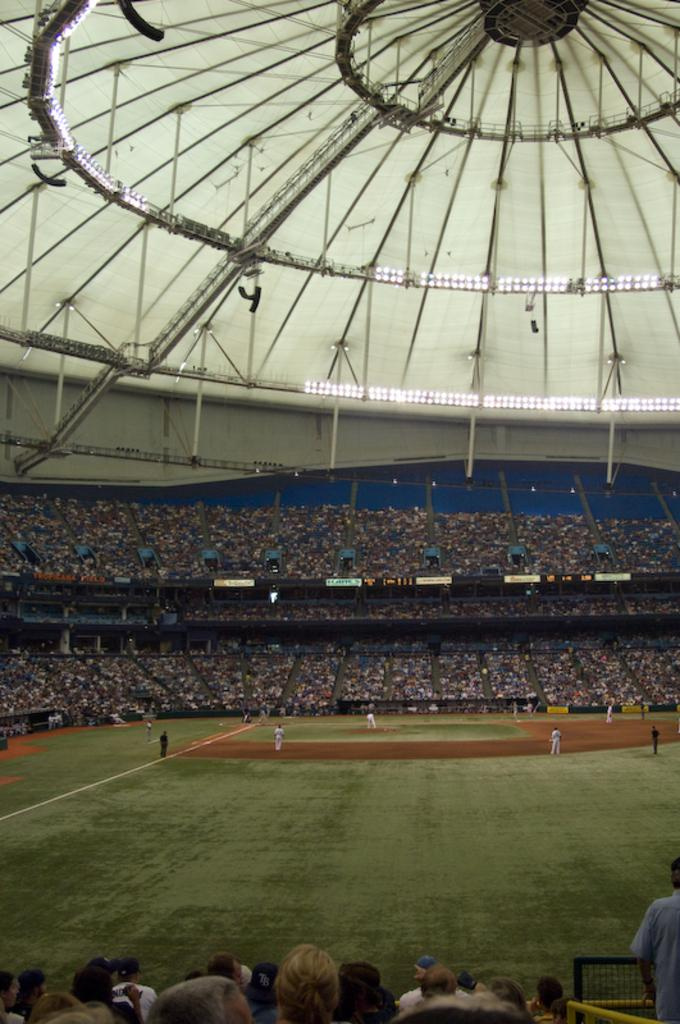What type of structure is shown in the image? There is a stadium in the image. Can you describe the people in the image? There is a group of people in the image, and some of them are standing on the ground. What type of surface is visible in the image? There is grass visible in the image. What marking can be seen on the ground? There is a white line on the ground. What historical event is being commemorated by the group of people in the image? There is no indication of a historical event being commemorated in the image; it simply shows a group of people standing on the grass near a stadium. 